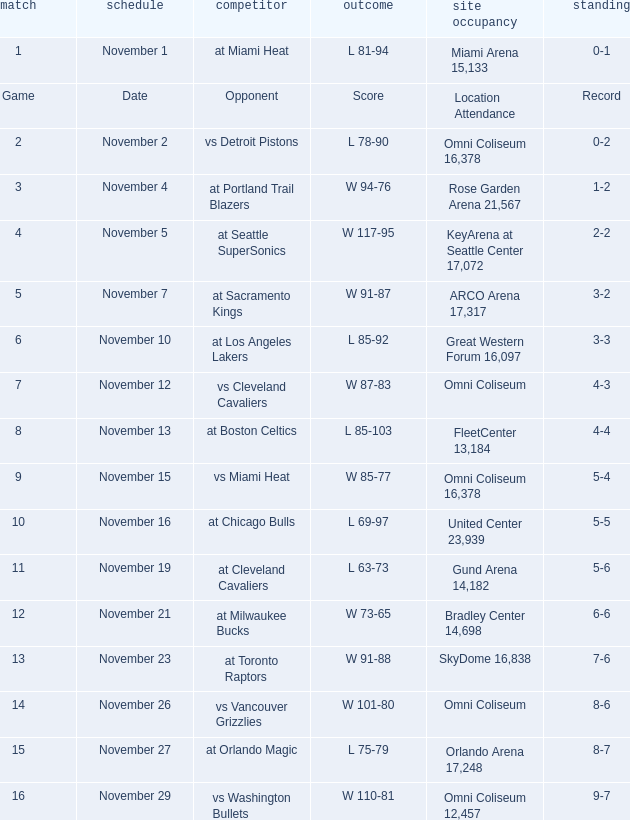On what date was game 3? November 4. 